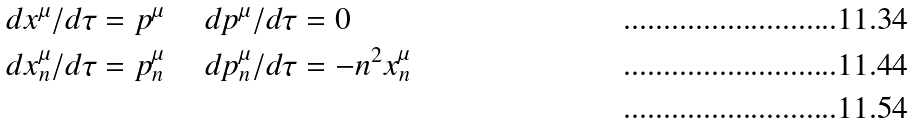Convert formula to latex. <formula><loc_0><loc_0><loc_500><loc_500>d x ^ { \mu } / d \tau = p ^ { \mu } & \quad \ d p ^ { \mu } / d \tau = 0 \\ d x ^ { \mu } _ { n } / d \tau = p ^ { \mu } _ { n } & \quad \ d p ^ { \mu } _ { n } / d \tau = - n ^ { 2 } x ^ { \mu } _ { n } \\</formula> 